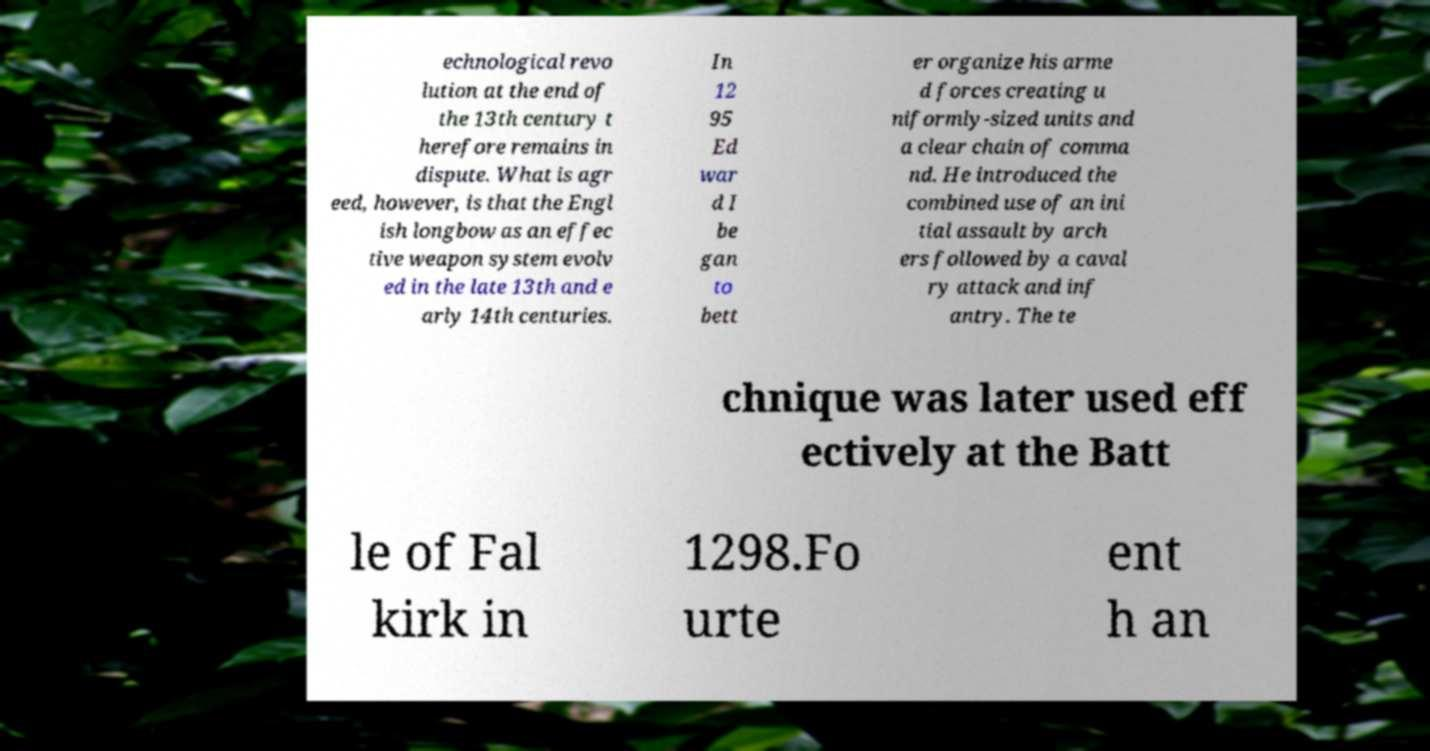Can you accurately transcribe the text from the provided image for me? echnological revo lution at the end of the 13th century t herefore remains in dispute. What is agr eed, however, is that the Engl ish longbow as an effec tive weapon system evolv ed in the late 13th and e arly 14th centuries. In 12 95 Ed war d I be gan to bett er organize his arme d forces creating u niformly-sized units and a clear chain of comma nd. He introduced the combined use of an ini tial assault by arch ers followed by a caval ry attack and inf antry. The te chnique was later used eff ectively at the Batt le of Fal kirk in 1298.Fo urte ent h an 